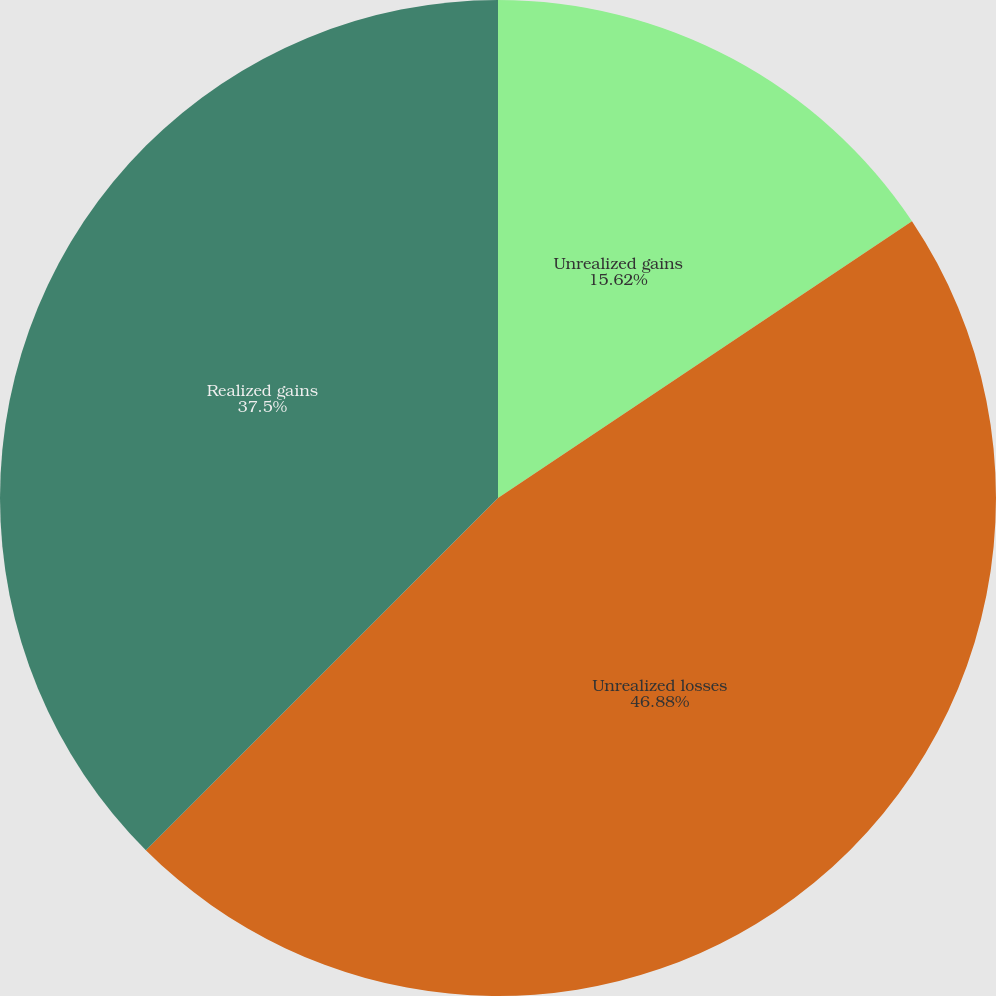Convert chart. <chart><loc_0><loc_0><loc_500><loc_500><pie_chart><fcel>Unrealized gains<fcel>Unrealized losses<fcel>Realized gains<nl><fcel>15.62%<fcel>46.88%<fcel>37.5%<nl></chart> 